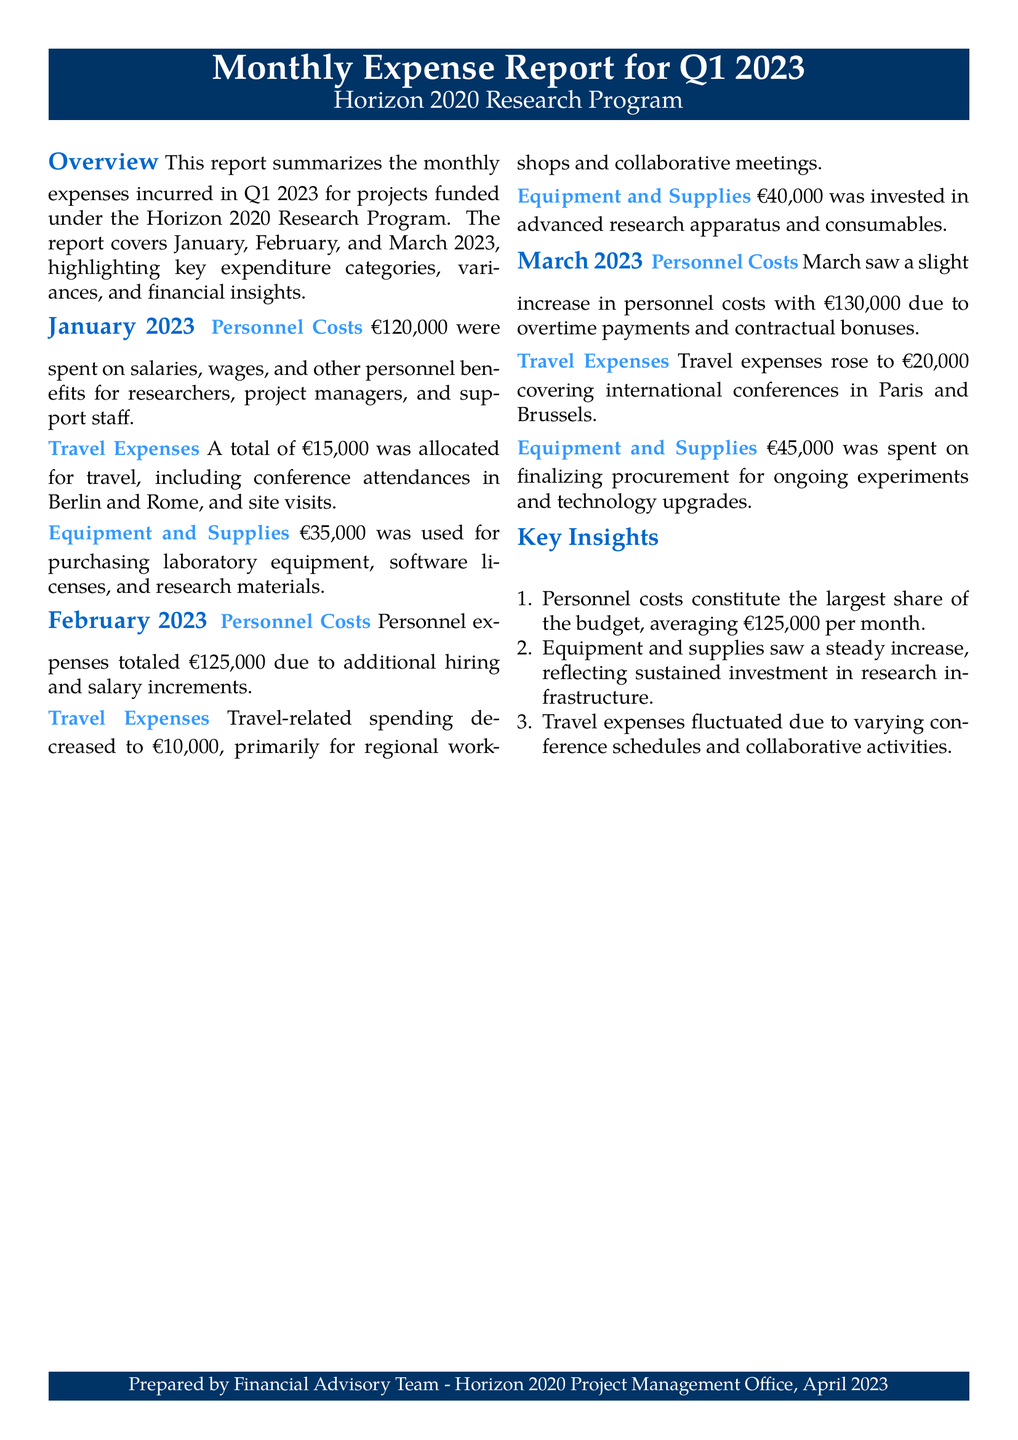what was the total personnel cost in January 2023? The total personnel cost in January 2023 is listed in the document, which is €120,000.
Answer: €120,000 how much was spent on travel expenses in February 2023? The expenditure for travel expenses in February 2023 is stated as €10,000 in the document.
Answer: €10,000 what is the average monthly personnel cost for Q1 2023? The average monthly personnel cost can be calculated from January, February, and March costs, which are €120,000, €125,000, and €130,000 respectively, giving an average of €125,000.
Answer: €125,000 how much did equipment and supplies cost in March 2023? The cost for equipment and supplies in March 2023 is specified in the document as €45,000.
Answer: €45,000 which month had the highest travel expenses? By analyzing the travel expenses for the three months, March had the highest travel expenses at €20,000.
Answer: March what is the main insight regarding personnel costs? The key insight about personnel costs states that they constitute the largest share of the budget, averaging €125,000 per month.
Answer: Largest share of the budget how much was invested in equipment and supplies in February 2023? The amount invested in equipment and supplies in February 2023 is clearly mentioned as €40,000 in the document.
Answer: €40,000 what was the total travel expense across all three months? The total travel expense can be calculated by summing the expenses from all three months: €15,000 + €10,000 + €20,000 = €45,000.
Answer: €45,000 what was the personnel cost increase from January to March 2023? The personnel costs increased from €120,000 in January to €130,000 in March, which signifies a €10,000 increase.
Answer: €10,000 